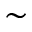<formula> <loc_0><loc_0><loc_500><loc_500>\sim</formula> 